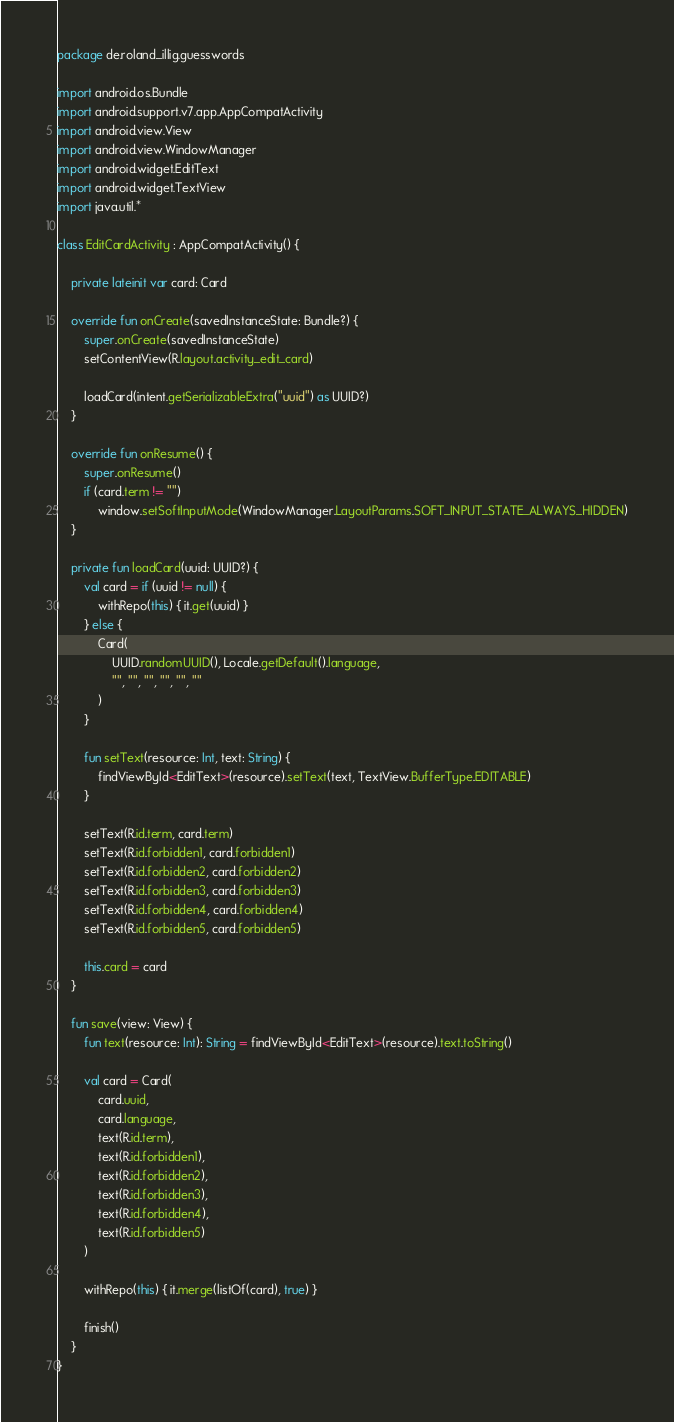Convert code to text. <code><loc_0><loc_0><loc_500><loc_500><_Kotlin_>package de.roland_illig.guesswords

import android.os.Bundle
import android.support.v7.app.AppCompatActivity
import android.view.View
import android.view.WindowManager
import android.widget.EditText
import android.widget.TextView
import java.util.*

class EditCardActivity : AppCompatActivity() {

    private lateinit var card: Card

    override fun onCreate(savedInstanceState: Bundle?) {
        super.onCreate(savedInstanceState)
        setContentView(R.layout.activity_edit_card)

        loadCard(intent.getSerializableExtra("uuid") as UUID?)
    }

    override fun onResume() {
        super.onResume()
        if (card.term != "")
            window.setSoftInputMode(WindowManager.LayoutParams.SOFT_INPUT_STATE_ALWAYS_HIDDEN)
    }

    private fun loadCard(uuid: UUID?) {
        val card = if (uuid != null) {
            withRepo(this) { it.get(uuid) }
        } else {
            Card(
                UUID.randomUUID(), Locale.getDefault().language,
                "", "", "", "", "", ""
            )
        }

        fun setText(resource: Int, text: String) {
            findViewById<EditText>(resource).setText(text, TextView.BufferType.EDITABLE)
        }

        setText(R.id.term, card.term)
        setText(R.id.forbidden1, card.forbidden1)
        setText(R.id.forbidden2, card.forbidden2)
        setText(R.id.forbidden3, card.forbidden3)
        setText(R.id.forbidden4, card.forbidden4)
        setText(R.id.forbidden5, card.forbidden5)

        this.card = card
    }

    fun save(view: View) {
        fun text(resource: Int): String = findViewById<EditText>(resource).text.toString()

        val card = Card(
            card.uuid,
            card.language,
            text(R.id.term),
            text(R.id.forbidden1),
            text(R.id.forbidden2),
            text(R.id.forbidden3),
            text(R.id.forbidden4),
            text(R.id.forbidden5)
        )

        withRepo(this) { it.merge(listOf(card), true) }

        finish()
    }
}
</code> 